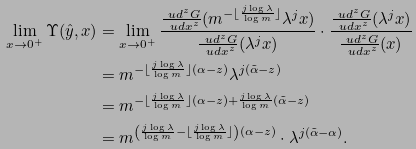Convert formula to latex. <formula><loc_0><loc_0><loc_500><loc_500>\lim _ { x \to 0 ^ { + } } \Upsilon ( \hat { y } , x ) & = \lim _ { x \to 0 ^ { + } } \frac { \frac { \ u d ^ { z } G } { \ u d x ^ { z } } ( m ^ { - \lfloor \frac { j \log \lambda } { \log m } \rfloor } \lambda ^ { j } x ) } { \frac { \ u d ^ { z } G } { \ u d x ^ { z } } ( \lambda ^ { j } x ) } \cdot \frac { \frac { \ u d ^ { z } G } { \ u d x ^ { z } } ( \lambda ^ { j } x ) } { \frac { \ u d ^ { z } G } { \ u d x ^ { z } } ( x ) } \\ & = m ^ { - \lfloor \frac { j \log \lambda } { \log m } \rfloor ( \alpha - z ) } \lambda ^ { j ( \tilde { \alpha } - z ) } \\ & = m ^ { - \lfloor \frac { j \log \lambda } { \log m } \rfloor ( \alpha - z ) + \frac { j \log \lambda } { \log m } ( \tilde { \alpha } - z ) } \\ & = m ^ { \left ( \frac { j \log \lambda } { \log m } - \lfloor \frac { j \log \lambda } { \log m } \rfloor \right ) ( \alpha - z ) } \cdot \lambda ^ { j ( \tilde { \alpha } - \alpha ) } .</formula> 